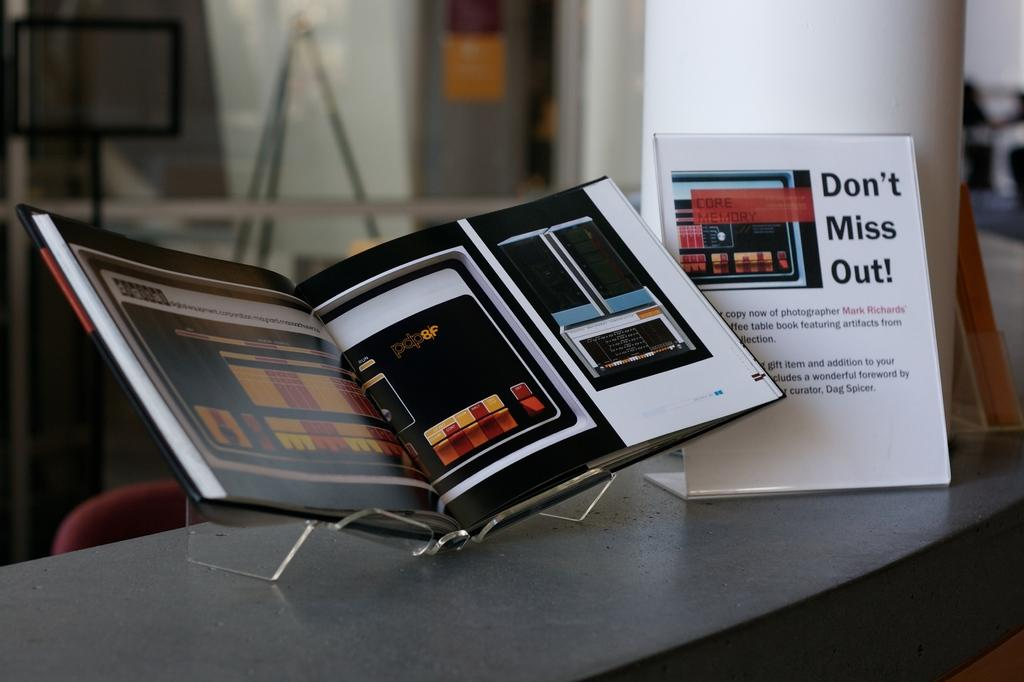<image>
Summarize the visual content of the image. An open book sitting on a gray table with an advertisement stand next to the open box that says "Don't Miss out!" 